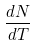Convert formula to latex. <formula><loc_0><loc_0><loc_500><loc_500>\frac { d N } { d T }</formula> 